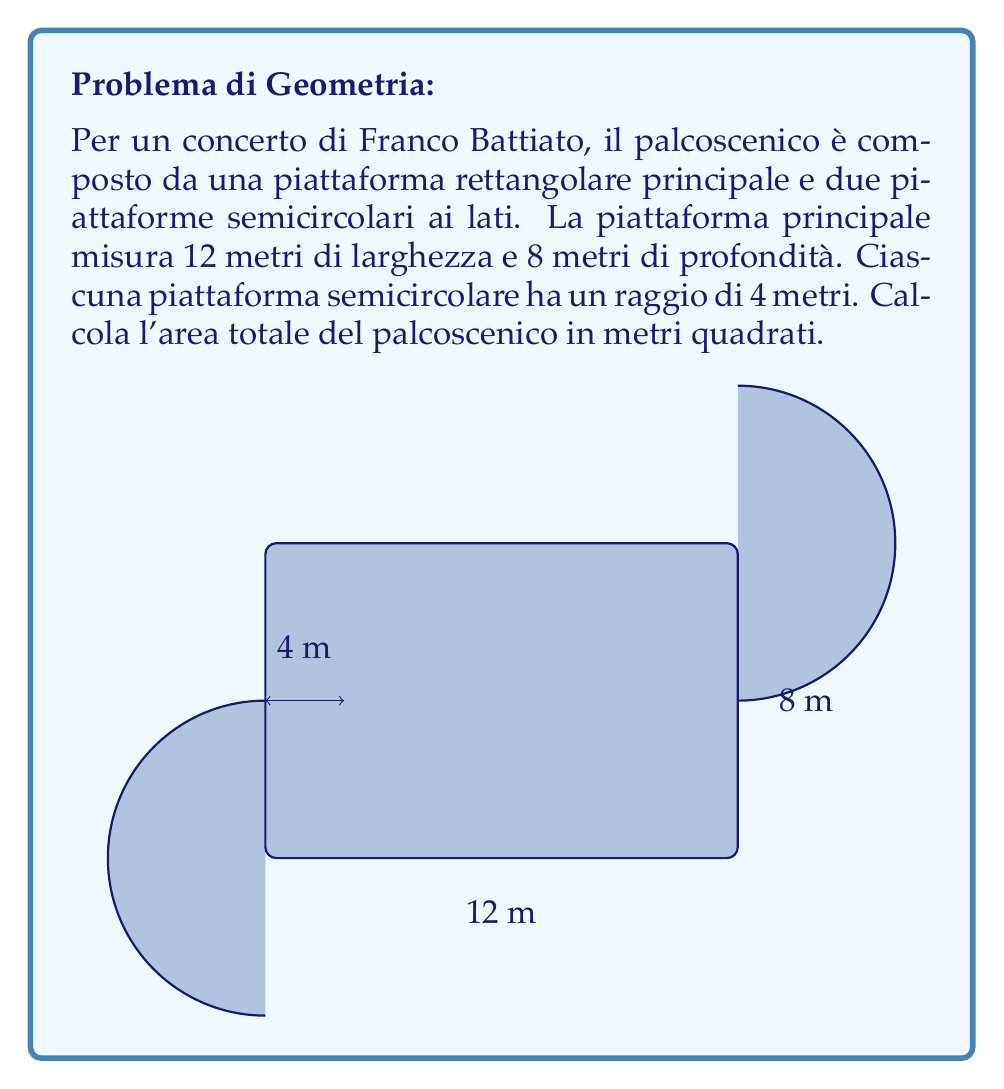Give your solution to this math problem. Per risolvere questo problema, dobbiamo:

1) Calcolare l'area della piattaforma rettangolare principale
2) Calcolare l'area di ciascuna piattaforma semicircolare
3) Sommare tutte le aree

1. Area della piattaforma principale:
   $$A_{rettangolo} = lunghezza \times larghezza = 12 \text{ m} \times 8 \text{ m} = 96 \text{ m}^2$$

2. Area di una piattaforma semicircolare:
   L'area di un cerchio completo è $\pi r^2$, quindi l'area di un semicerchio è la metà di questa.
   $$A_{semicerchio} = \frac{1}{2} \pi r^2 = \frac{1}{2} \pi (4 \text{ m})^2 = 8\pi \text{ m}^2$$
   
   Poiché ci sono due piattaforme semicircolari, l'area totale dei semicerchi è:
   $$A_{semicerchi} = 2 \times 8\pi \text{ m}^2 = 16\pi \text{ m}^2$$

3. Area totale del palcoscenico:
   $$A_{totale} = A_{rettangolo} + A_{semicerchi} = 96 \text{ m}^2 + 16\pi \text{ m}^2$$

   $$A_{totale} = 96 + 16\pi \text{ m}^2 \approx 146.19 \text{ m}^2$$
Answer: L'area totale del palcoscenico è $96 + 16\pi \text{ m}^2$ o approssimativamente $146.19 \text{ m}^2$. 